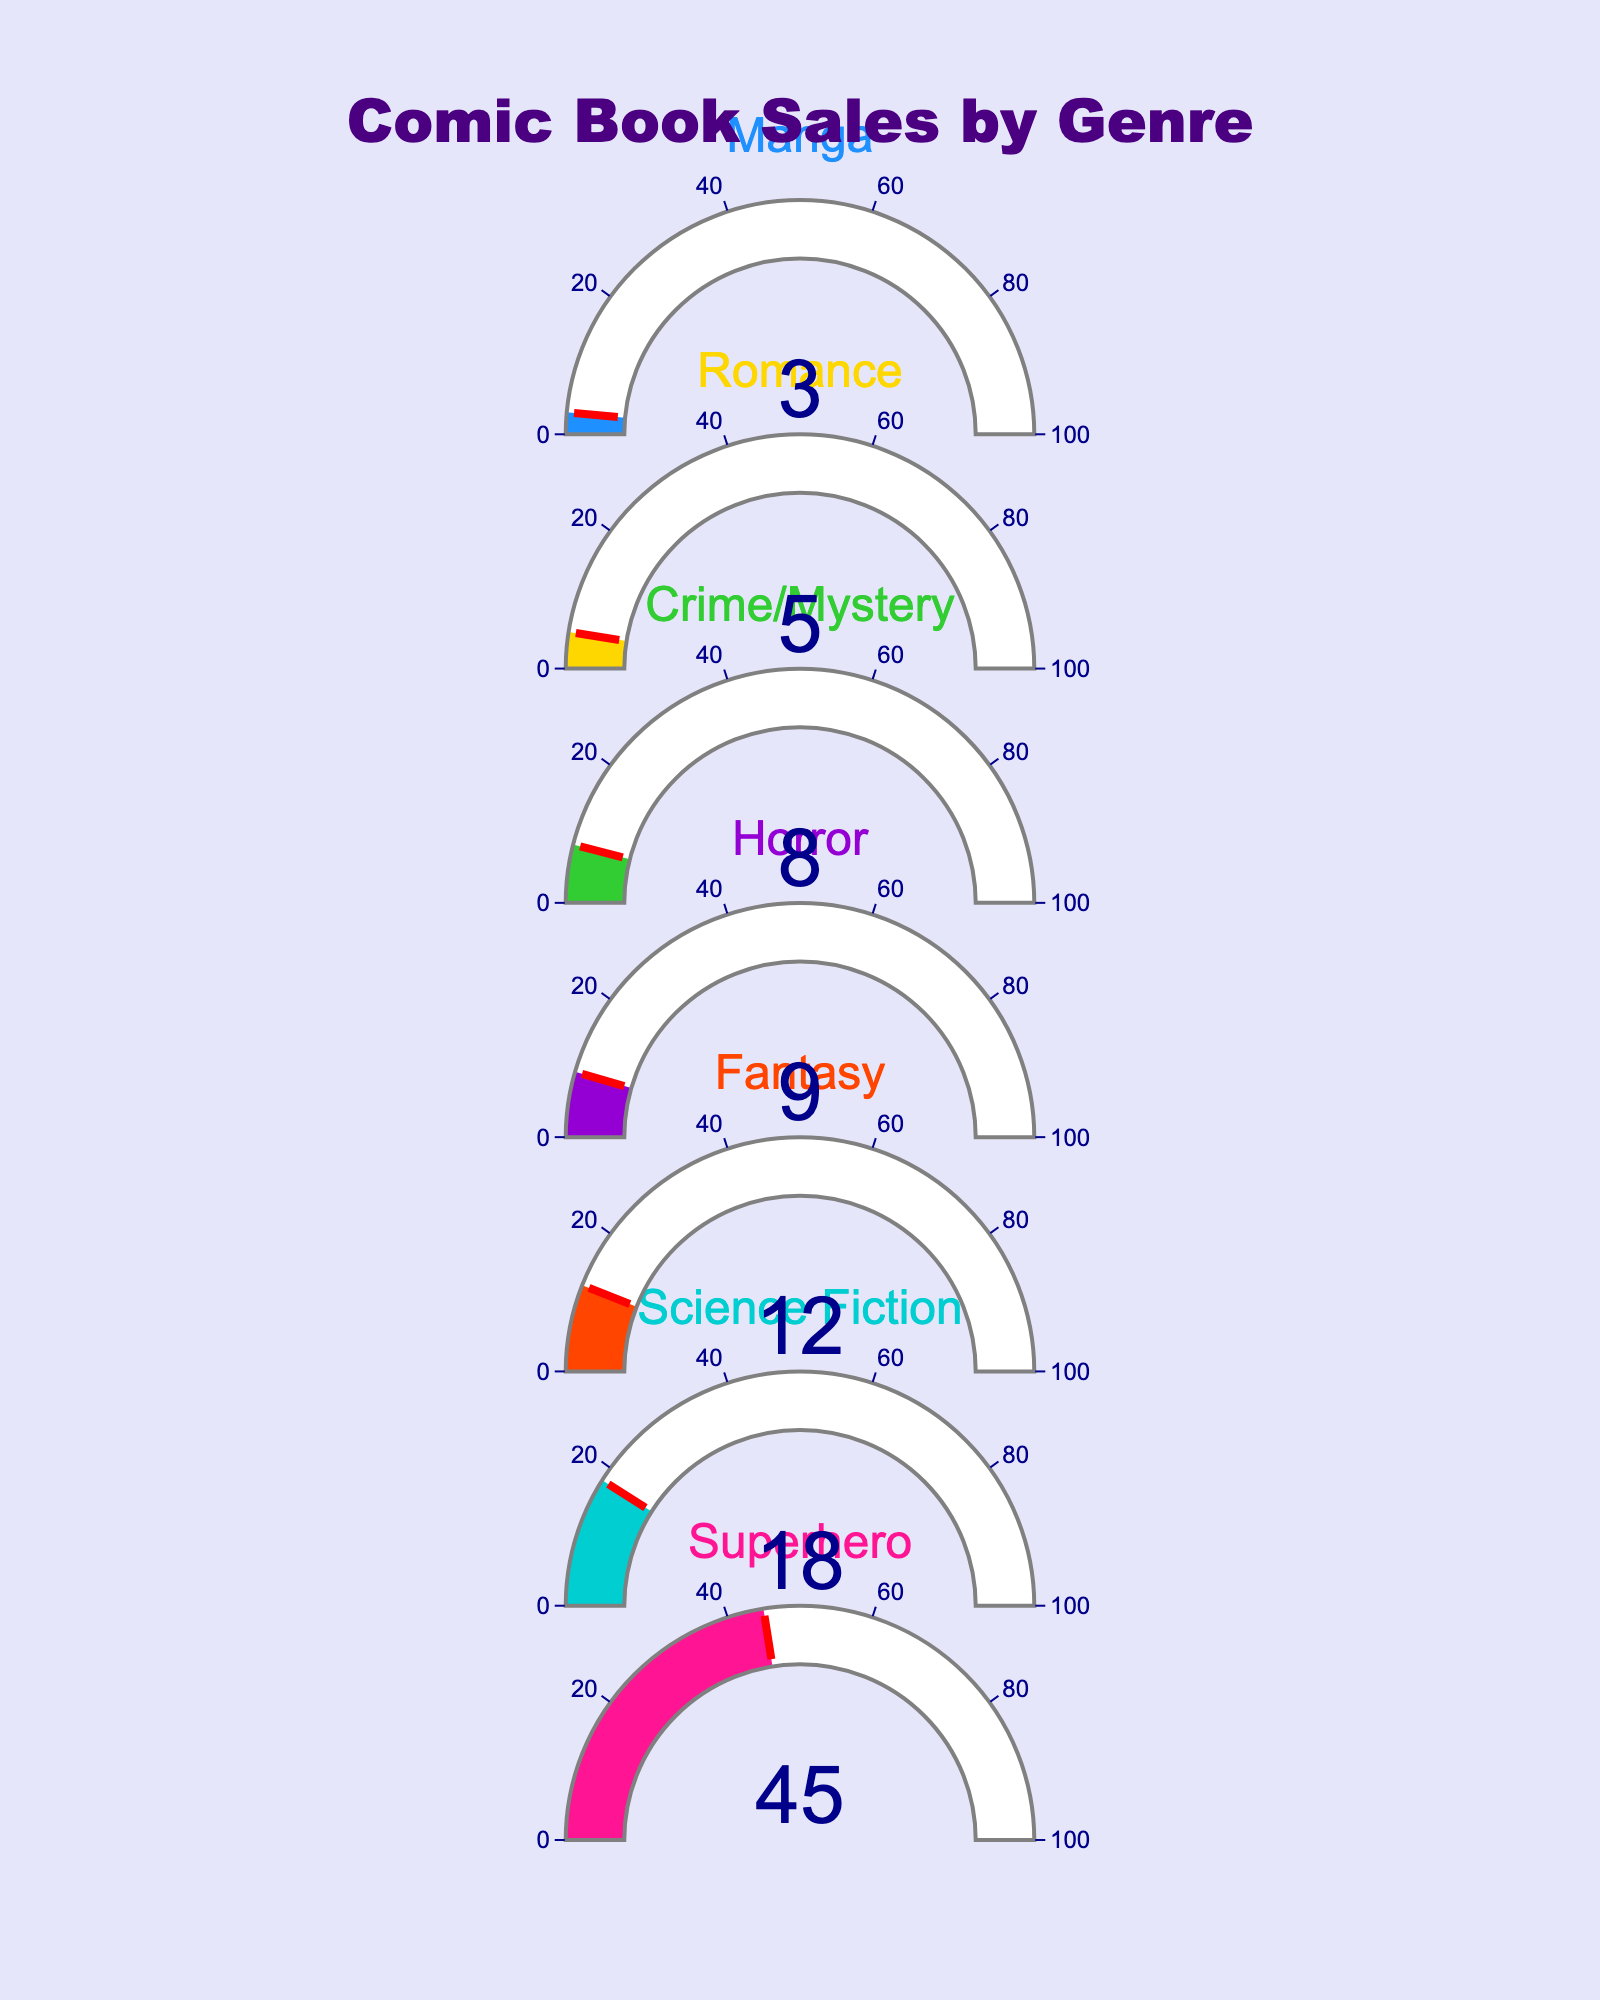Which genre has the highest percentage of comic book sales? The gauge chart shows the percentage of comic book sales for each genre. The genre with the highest percentage is 45%, which is Superhero.
Answer: Superhero What is the sum of the percentages for Science Fiction and Fantasy genres? The gauge chart shows the individual percentages for Science Fiction (18%) and Fantasy (12%). Adding these together gives 18% + 12% = 30%.
Answer: 30% Which genres have a percentage of comic book sales greater than 10%? The gauge chart provides the percentages for all genres. The genres with percentages greater than 10% are Superhero (45%), Science Fiction (18%), and Fantasy (12%).
Answer: Superhero, Science Fiction, Fantasy How much higher is the percentage of Horror sales compared to Romance sales? The gauge chart shows Horror at 9% and Romance at 5%. The difference is 9% - 5% = 4%.
Answer: 4% What is the median percentage of comic book sales among the genres? To find the median, list all the percentages in order: 3%, 5%, 8%, 9%, 12%, 18%, 45%. The middle value (median) in this list is 9%.
Answer: 9% How does the percentage of Crime/Mystery comic book sales compare to Manga sales? The gauge chart shows Crime/Mystery at 8% and Manga at 3%. Crime/Mystery has a higher percentage than Manga.
Answer: Crime/Mystery > Manga What is the percentage difference between the highest and lowest comic book sales genres? The highest percentage is for Superhero (45%) and the lowest is for Manga (3%). The difference is 45% - 3% = 42%.
Answer: 42% If the percentage of Superhero sales is 45%, by how much would it need to increase to reach 50%? The current percentage of Superhero sales is 45%. To find the needed increase to reach 50%, calculate 50% - 45% = 5%.
Answer: 5% What's the total percentage of comic book sales covered by Horror, Crime/Mystery, and Romance genres combined? The individual percentages are Horror (9%), Crime/Mystery (8%), and Romance (5%). Adding these together gives 9% + 8% + 5% = 22%.
Answer: 22% 